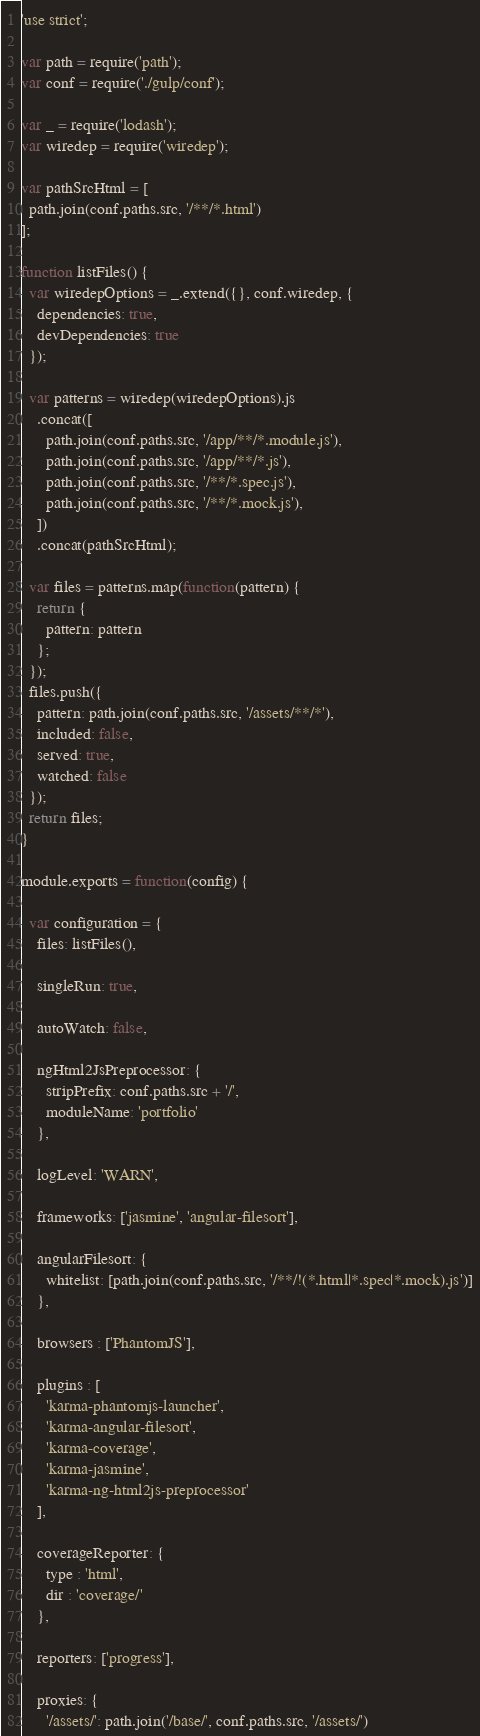<code> <loc_0><loc_0><loc_500><loc_500><_JavaScript_>'use strict';

var path = require('path');
var conf = require('./gulp/conf');

var _ = require('lodash');
var wiredep = require('wiredep');

var pathSrcHtml = [
  path.join(conf.paths.src, '/**/*.html')
];

function listFiles() {
  var wiredepOptions = _.extend({}, conf.wiredep, {
    dependencies: true,
    devDependencies: true
  });

  var patterns = wiredep(wiredepOptions).js
    .concat([
      path.join(conf.paths.src, '/app/**/*.module.js'),
      path.join(conf.paths.src, '/app/**/*.js'),
      path.join(conf.paths.src, '/**/*.spec.js'),
      path.join(conf.paths.src, '/**/*.mock.js'),
    ])
    .concat(pathSrcHtml);

  var files = patterns.map(function(pattern) {
    return {
      pattern: pattern
    };
  });
  files.push({
    pattern: path.join(conf.paths.src, '/assets/**/*'),
    included: false,
    served: true,
    watched: false
  });
  return files;
}

module.exports = function(config) {

  var configuration = {
    files: listFiles(),

    singleRun: true,

    autoWatch: false,

    ngHtml2JsPreprocessor: {
      stripPrefix: conf.paths.src + '/',
      moduleName: 'portfolio'
    },

    logLevel: 'WARN',

    frameworks: ['jasmine', 'angular-filesort'],

    angularFilesort: {
      whitelist: [path.join(conf.paths.src, '/**/!(*.html|*.spec|*.mock).js')]
    },

    browsers : ['PhantomJS'],

    plugins : [
      'karma-phantomjs-launcher',
      'karma-angular-filesort',
      'karma-coverage',
      'karma-jasmine',
      'karma-ng-html2js-preprocessor'
    ],

    coverageReporter: {
      type : 'html',
      dir : 'coverage/'
    },

    reporters: ['progress'],

    proxies: {
      '/assets/': path.join('/base/', conf.paths.src, '/assets/')</code> 